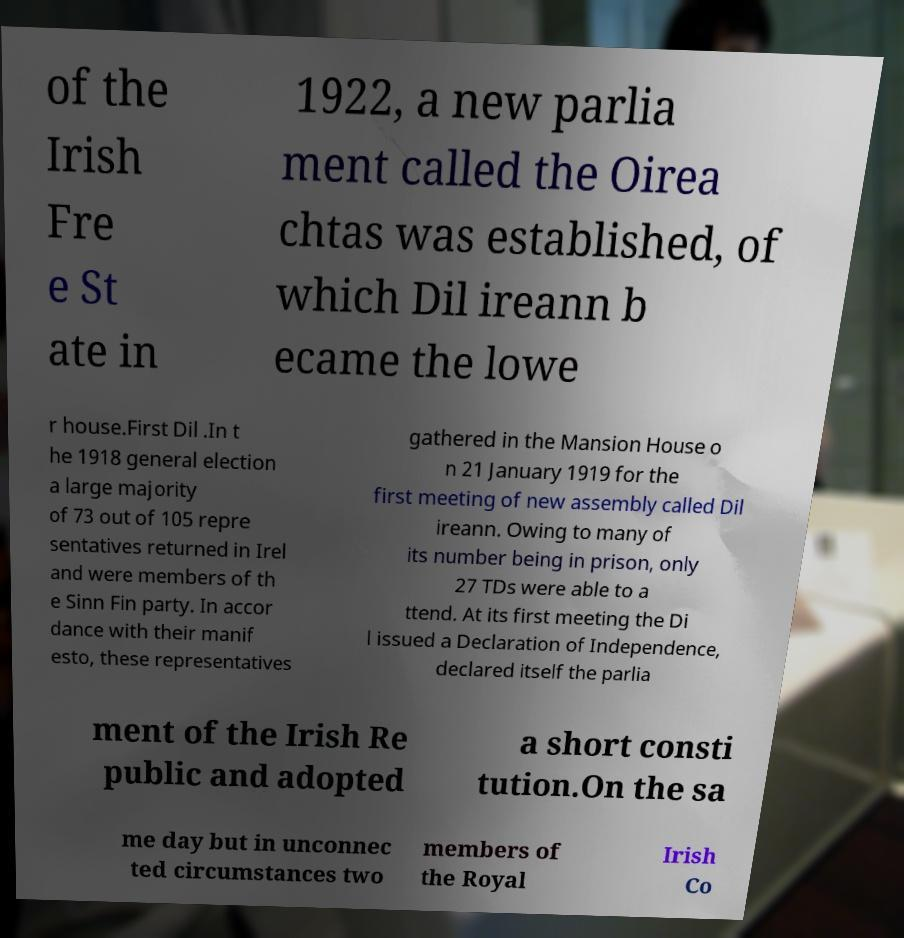Could you assist in decoding the text presented in this image and type it out clearly? of the Irish Fre e St ate in 1922, a new parlia ment called the Oirea chtas was established, of which Dil ireann b ecame the lowe r house.First Dil .In t he 1918 general election a large majority of 73 out of 105 repre sentatives returned in Irel and were members of th e Sinn Fin party. In accor dance with their manif esto, these representatives gathered in the Mansion House o n 21 January 1919 for the first meeting of new assembly called Dil ireann. Owing to many of its number being in prison, only 27 TDs were able to a ttend. At its first meeting the Di l issued a Declaration of Independence, declared itself the parlia ment of the Irish Re public and adopted a short consti tution.On the sa me day but in unconnec ted circumstances two members of the Royal Irish Co 